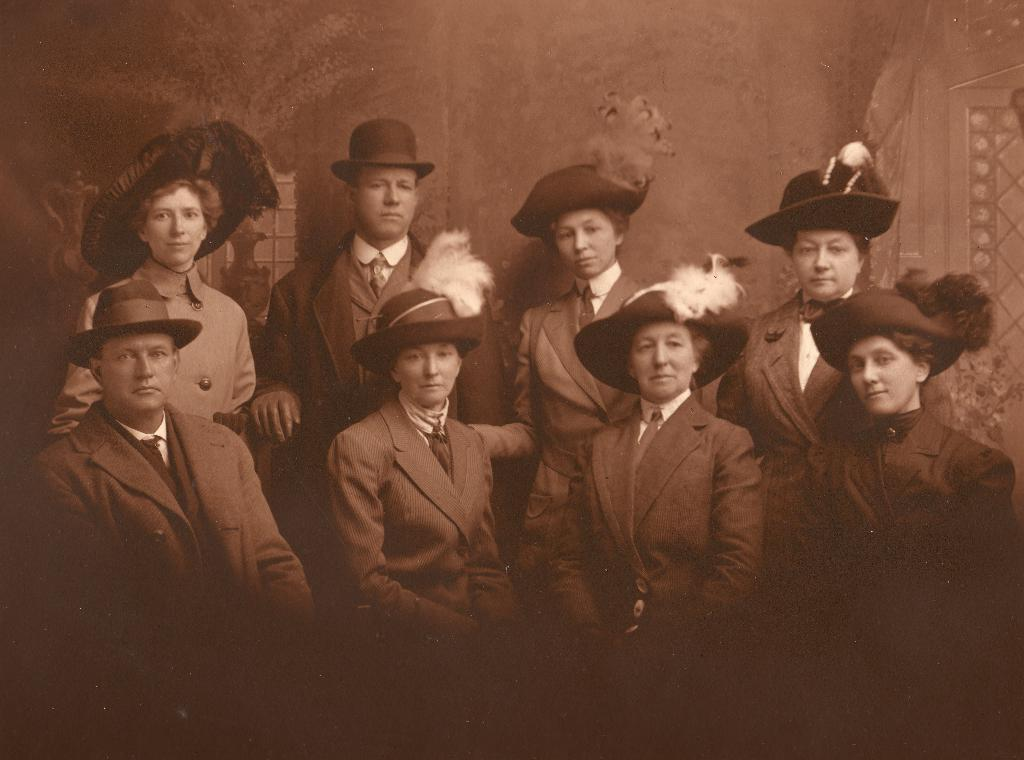What are the people in the image wearing on their heads? The people in the image are wearing hats. What can be seen in the distance behind the people? There is a wall in the background of the image. What else is visible in the background of the image? There are objects visible in the background of the image. How many fairies can be seen flying around the people in the image? There are no fairies present in the image. What is the weight of the vase visible in the background of the image? There is no vase present in the image, so it is not possible to determine its weight. 